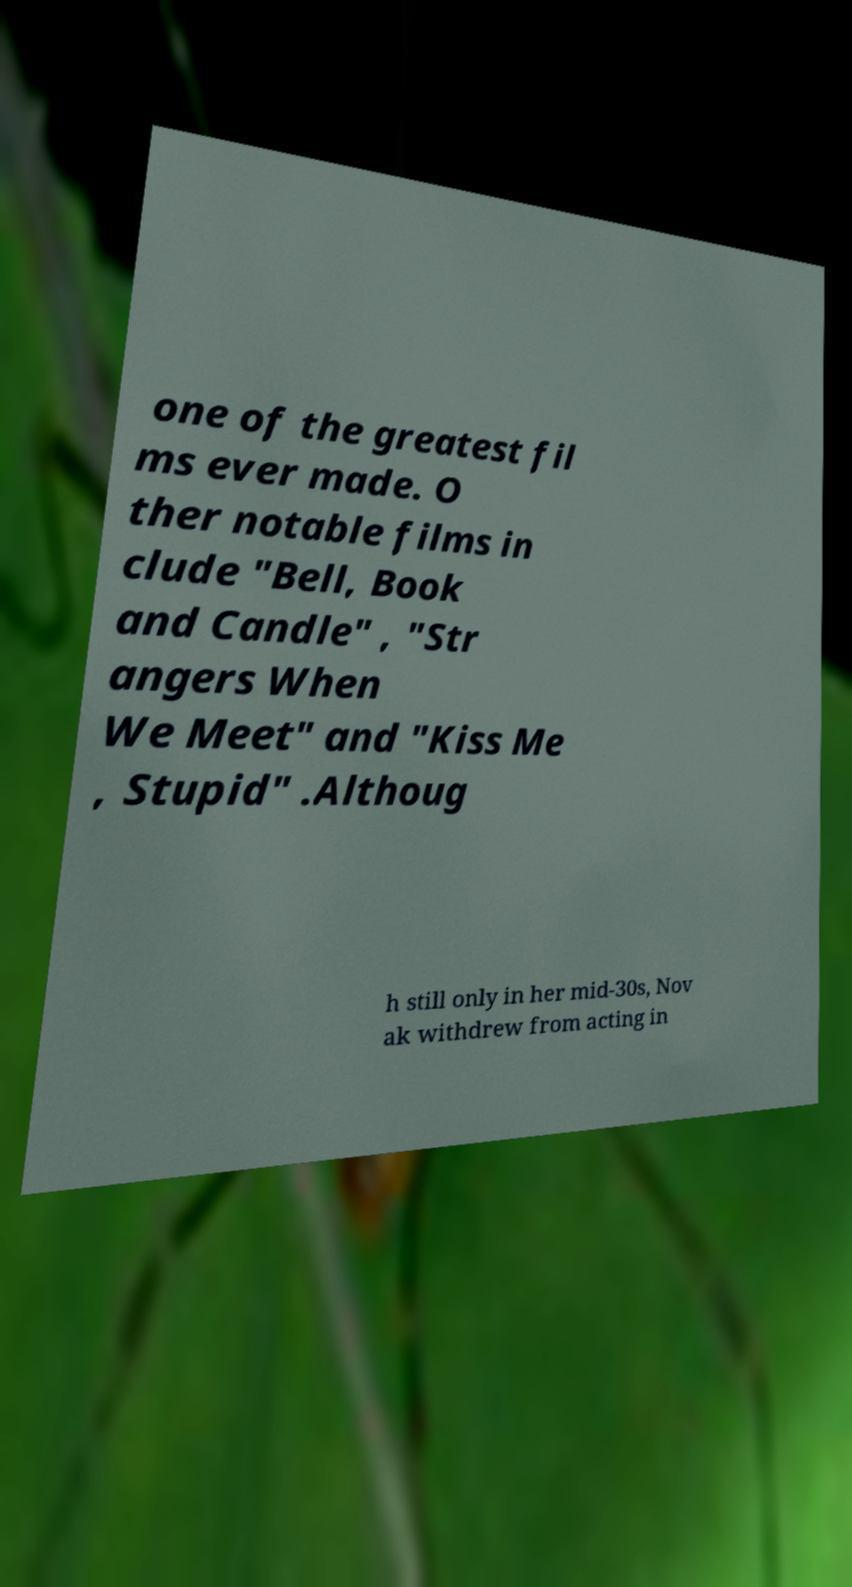I need the written content from this picture converted into text. Can you do that? one of the greatest fil ms ever made. O ther notable films in clude "Bell, Book and Candle" , "Str angers When We Meet" and "Kiss Me , Stupid" .Althoug h still only in her mid-30s, Nov ak withdrew from acting in 